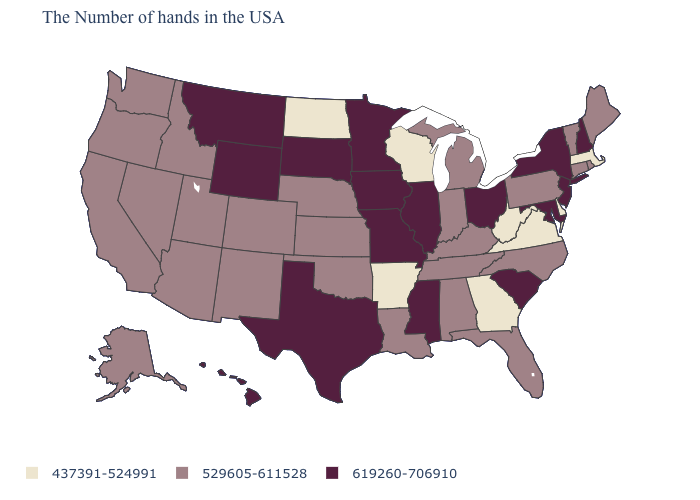Name the states that have a value in the range 437391-524991?
Keep it brief. Massachusetts, Delaware, Virginia, West Virginia, Georgia, Wisconsin, Arkansas, North Dakota. What is the value of New Jersey?
Be succinct. 619260-706910. Name the states that have a value in the range 437391-524991?
Concise answer only. Massachusetts, Delaware, Virginia, West Virginia, Georgia, Wisconsin, Arkansas, North Dakota. Among the states that border Delaware , does New Jersey have the highest value?
Concise answer only. Yes. Which states have the lowest value in the USA?
Give a very brief answer. Massachusetts, Delaware, Virginia, West Virginia, Georgia, Wisconsin, Arkansas, North Dakota. Name the states that have a value in the range 619260-706910?
Give a very brief answer. New Hampshire, New York, New Jersey, Maryland, South Carolina, Ohio, Illinois, Mississippi, Missouri, Minnesota, Iowa, Texas, South Dakota, Wyoming, Montana, Hawaii. What is the lowest value in the Northeast?
Give a very brief answer. 437391-524991. Does the first symbol in the legend represent the smallest category?
Quick response, please. Yes. What is the highest value in the MidWest ?
Write a very short answer. 619260-706910. Does the first symbol in the legend represent the smallest category?
Give a very brief answer. Yes. Among the states that border Georgia , which have the lowest value?
Be succinct. North Carolina, Florida, Alabama, Tennessee. Which states have the highest value in the USA?
Short answer required. New Hampshire, New York, New Jersey, Maryland, South Carolina, Ohio, Illinois, Mississippi, Missouri, Minnesota, Iowa, Texas, South Dakota, Wyoming, Montana, Hawaii. Which states have the lowest value in the MidWest?
Write a very short answer. Wisconsin, North Dakota. Does Oklahoma have a lower value than Rhode Island?
Quick response, please. No. Which states have the highest value in the USA?
Concise answer only. New Hampshire, New York, New Jersey, Maryland, South Carolina, Ohio, Illinois, Mississippi, Missouri, Minnesota, Iowa, Texas, South Dakota, Wyoming, Montana, Hawaii. 